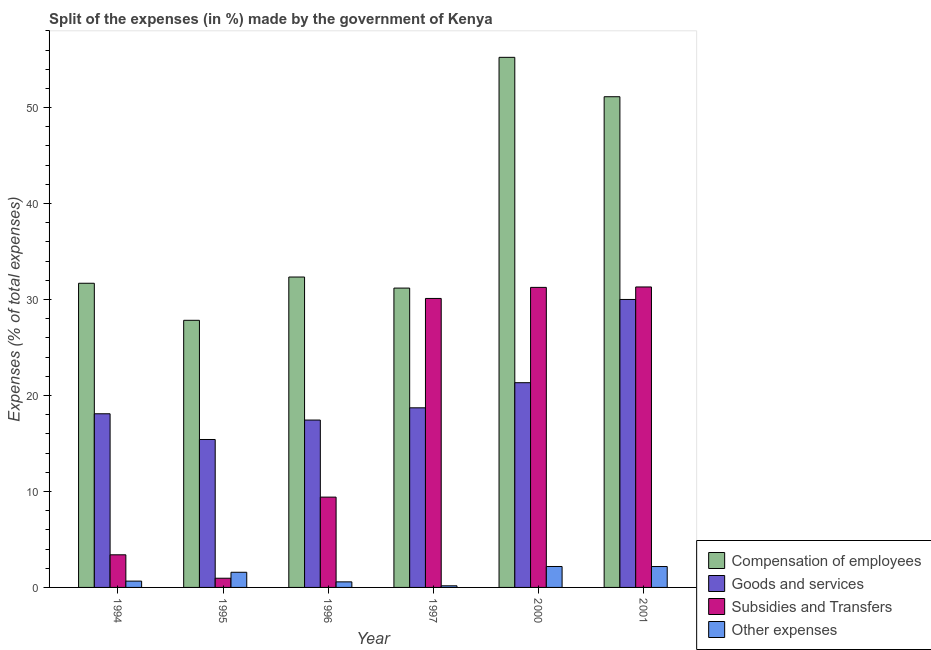How many different coloured bars are there?
Provide a succinct answer. 4. How many groups of bars are there?
Give a very brief answer. 6. Are the number of bars per tick equal to the number of legend labels?
Keep it short and to the point. Yes. How many bars are there on the 1st tick from the left?
Keep it short and to the point. 4. How many bars are there on the 5th tick from the right?
Make the answer very short. 4. What is the label of the 2nd group of bars from the left?
Provide a short and direct response. 1995. What is the percentage of amount spent on goods and services in 1994?
Ensure brevity in your answer.  18.1. Across all years, what is the maximum percentage of amount spent on compensation of employees?
Offer a terse response. 55.24. Across all years, what is the minimum percentage of amount spent on other expenses?
Your response must be concise. 0.17. What is the total percentage of amount spent on compensation of employees in the graph?
Make the answer very short. 229.44. What is the difference between the percentage of amount spent on subsidies in 1994 and that in 1995?
Ensure brevity in your answer.  2.44. What is the difference between the percentage of amount spent on compensation of employees in 1995 and the percentage of amount spent on goods and services in 2001?
Give a very brief answer. -23.3. What is the average percentage of amount spent on other expenses per year?
Your answer should be very brief. 1.22. In the year 1995, what is the difference between the percentage of amount spent on goods and services and percentage of amount spent on other expenses?
Provide a short and direct response. 0. In how many years, is the percentage of amount spent on subsidies greater than 50 %?
Your answer should be very brief. 0. What is the ratio of the percentage of amount spent on other expenses in 1997 to that in 2001?
Provide a succinct answer. 0.08. Is the percentage of amount spent on compensation of employees in 1997 less than that in 2000?
Keep it short and to the point. Yes. What is the difference between the highest and the second highest percentage of amount spent on compensation of employees?
Provide a succinct answer. 4.11. What is the difference between the highest and the lowest percentage of amount spent on subsidies?
Your answer should be very brief. 30.35. What does the 2nd bar from the left in 1997 represents?
Your response must be concise. Goods and services. What does the 4th bar from the right in 2000 represents?
Provide a short and direct response. Compensation of employees. Are all the bars in the graph horizontal?
Provide a succinct answer. No. How many years are there in the graph?
Keep it short and to the point. 6. What is the difference between two consecutive major ticks on the Y-axis?
Ensure brevity in your answer.  10. Are the values on the major ticks of Y-axis written in scientific E-notation?
Make the answer very short. No. Does the graph contain any zero values?
Your response must be concise. No. Does the graph contain grids?
Your answer should be compact. No. Where does the legend appear in the graph?
Ensure brevity in your answer.  Bottom right. What is the title of the graph?
Give a very brief answer. Split of the expenses (in %) made by the government of Kenya. Does "Services" appear as one of the legend labels in the graph?
Your response must be concise. No. What is the label or title of the Y-axis?
Keep it short and to the point. Expenses (% of total expenses). What is the Expenses (% of total expenses) in Compensation of employees in 1994?
Offer a very short reply. 31.7. What is the Expenses (% of total expenses) of Goods and services in 1994?
Offer a very short reply. 18.1. What is the Expenses (% of total expenses) of Subsidies and Transfers in 1994?
Ensure brevity in your answer.  3.4. What is the Expenses (% of total expenses) of Other expenses in 1994?
Your response must be concise. 0.66. What is the Expenses (% of total expenses) in Compensation of employees in 1995?
Provide a short and direct response. 27.84. What is the Expenses (% of total expenses) in Goods and services in 1995?
Keep it short and to the point. 15.42. What is the Expenses (% of total expenses) of Subsidies and Transfers in 1995?
Ensure brevity in your answer.  0.96. What is the Expenses (% of total expenses) in Other expenses in 1995?
Keep it short and to the point. 1.58. What is the Expenses (% of total expenses) of Compensation of employees in 1996?
Offer a very short reply. 32.35. What is the Expenses (% of total expenses) in Goods and services in 1996?
Give a very brief answer. 17.44. What is the Expenses (% of total expenses) in Subsidies and Transfers in 1996?
Ensure brevity in your answer.  9.41. What is the Expenses (% of total expenses) of Other expenses in 1996?
Give a very brief answer. 0.58. What is the Expenses (% of total expenses) of Compensation of employees in 1997?
Offer a very short reply. 31.19. What is the Expenses (% of total expenses) in Goods and services in 1997?
Make the answer very short. 18.72. What is the Expenses (% of total expenses) in Subsidies and Transfers in 1997?
Offer a terse response. 30.11. What is the Expenses (% of total expenses) of Other expenses in 1997?
Make the answer very short. 0.17. What is the Expenses (% of total expenses) of Compensation of employees in 2000?
Offer a very short reply. 55.24. What is the Expenses (% of total expenses) of Goods and services in 2000?
Offer a very short reply. 21.33. What is the Expenses (% of total expenses) of Subsidies and Transfers in 2000?
Your answer should be compact. 31.27. What is the Expenses (% of total expenses) of Other expenses in 2000?
Offer a terse response. 2.18. What is the Expenses (% of total expenses) in Compensation of employees in 2001?
Provide a short and direct response. 51.13. What is the Expenses (% of total expenses) of Goods and services in 2001?
Offer a very short reply. 30.01. What is the Expenses (% of total expenses) in Subsidies and Transfers in 2001?
Offer a terse response. 31.31. What is the Expenses (% of total expenses) of Other expenses in 2001?
Make the answer very short. 2.18. Across all years, what is the maximum Expenses (% of total expenses) in Compensation of employees?
Offer a terse response. 55.24. Across all years, what is the maximum Expenses (% of total expenses) of Goods and services?
Offer a terse response. 30.01. Across all years, what is the maximum Expenses (% of total expenses) in Subsidies and Transfers?
Your answer should be very brief. 31.31. Across all years, what is the maximum Expenses (% of total expenses) of Other expenses?
Your answer should be very brief. 2.18. Across all years, what is the minimum Expenses (% of total expenses) in Compensation of employees?
Offer a very short reply. 27.84. Across all years, what is the minimum Expenses (% of total expenses) in Goods and services?
Your response must be concise. 15.42. Across all years, what is the minimum Expenses (% of total expenses) in Subsidies and Transfers?
Ensure brevity in your answer.  0.96. Across all years, what is the minimum Expenses (% of total expenses) in Other expenses?
Your answer should be compact. 0.17. What is the total Expenses (% of total expenses) in Compensation of employees in the graph?
Offer a terse response. 229.44. What is the total Expenses (% of total expenses) of Goods and services in the graph?
Offer a terse response. 121.01. What is the total Expenses (% of total expenses) of Subsidies and Transfers in the graph?
Offer a terse response. 106.46. What is the total Expenses (% of total expenses) of Other expenses in the graph?
Your answer should be compact. 7.35. What is the difference between the Expenses (% of total expenses) in Compensation of employees in 1994 and that in 1995?
Provide a short and direct response. 3.86. What is the difference between the Expenses (% of total expenses) of Goods and services in 1994 and that in 1995?
Ensure brevity in your answer.  2.68. What is the difference between the Expenses (% of total expenses) of Subsidies and Transfers in 1994 and that in 1995?
Your answer should be compact. 2.44. What is the difference between the Expenses (% of total expenses) of Other expenses in 1994 and that in 1995?
Your answer should be very brief. -0.92. What is the difference between the Expenses (% of total expenses) in Compensation of employees in 1994 and that in 1996?
Provide a short and direct response. -0.65. What is the difference between the Expenses (% of total expenses) in Goods and services in 1994 and that in 1996?
Ensure brevity in your answer.  0.65. What is the difference between the Expenses (% of total expenses) of Subsidies and Transfers in 1994 and that in 1996?
Give a very brief answer. -6.01. What is the difference between the Expenses (% of total expenses) of Other expenses in 1994 and that in 1996?
Provide a succinct answer. 0.08. What is the difference between the Expenses (% of total expenses) in Compensation of employees in 1994 and that in 1997?
Provide a short and direct response. 0.5. What is the difference between the Expenses (% of total expenses) in Goods and services in 1994 and that in 1997?
Offer a terse response. -0.62. What is the difference between the Expenses (% of total expenses) in Subsidies and Transfers in 1994 and that in 1997?
Offer a very short reply. -26.72. What is the difference between the Expenses (% of total expenses) in Other expenses in 1994 and that in 1997?
Your answer should be compact. 0.49. What is the difference between the Expenses (% of total expenses) in Compensation of employees in 1994 and that in 2000?
Offer a very short reply. -23.54. What is the difference between the Expenses (% of total expenses) in Goods and services in 1994 and that in 2000?
Make the answer very short. -3.24. What is the difference between the Expenses (% of total expenses) in Subsidies and Transfers in 1994 and that in 2000?
Keep it short and to the point. -27.87. What is the difference between the Expenses (% of total expenses) in Other expenses in 1994 and that in 2000?
Provide a short and direct response. -1.52. What is the difference between the Expenses (% of total expenses) in Compensation of employees in 1994 and that in 2001?
Ensure brevity in your answer.  -19.44. What is the difference between the Expenses (% of total expenses) in Goods and services in 1994 and that in 2001?
Ensure brevity in your answer.  -11.91. What is the difference between the Expenses (% of total expenses) of Subsidies and Transfers in 1994 and that in 2001?
Offer a terse response. -27.91. What is the difference between the Expenses (% of total expenses) in Other expenses in 1994 and that in 2001?
Offer a very short reply. -1.52. What is the difference between the Expenses (% of total expenses) of Compensation of employees in 1995 and that in 1996?
Offer a very short reply. -4.51. What is the difference between the Expenses (% of total expenses) of Goods and services in 1995 and that in 1996?
Your answer should be compact. -2.03. What is the difference between the Expenses (% of total expenses) in Subsidies and Transfers in 1995 and that in 1996?
Offer a very short reply. -8.45. What is the difference between the Expenses (% of total expenses) of Compensation of employees in 1995 and that in 1997?
Your answer should be very brief. -3.36. What is the difference between the Expenses (% of total expenses) in Goods and services in 1995 and that in 1997?
Give a very brief answer. -3.3. What is the difference between the Expenses (% of total expenses) in Subsidies and Transfers in 1995 and that in 1997?
Your response must be concise. -29.16. What is the difference between the Expenses (% of total expenses) of Other expenses in 1995 and that in 1997?
Your answer should be very brief. 1.41. What is the difference between the Expenses (% of total expenses) of Compensation of employees in 1995 and that in 2000?
Your answer should be compact. -27.4. What is the difference between the Expenses (% of total expenses) of Goods and services in 1995 and that in 2000?
Provide a succinct answer. -5.92. What is the difference between the Expenses (% of total expenses) in Subsidies and Transfers in 1995 and that in 2000?
Provide a succinct answer. -30.31. What is the difference between the Expenses (% of total expenses) in Other expenses in 1995 and that in 2000?
Make the answer very short. -0.6. What is the difference between the Expenses (% of total expenses) of Compensation of employees in 1995 and that in 2001?
Your answer should be compact. -23.3. What is the difference between the Expenses (% of total expenses) of Goods and services in 1995 and that in 2001?
Make the answer very short. -14.59. What is the difference between the Expenses (% of total expenses) in Subsidies and Transfers in 1995 and that in 2001?
Ensure brevity in your answer.  -30.35. What is the difference between the Expenses (% of total expenses) in Other expenses in 1995 and that in 2001?
Offer a very short reply. -0.6. What is the difference between the Expenses (% of total expenses) of Compensation of employees in 1996 and that in 1997?
Ensure brevity in your answer.  1.15. What is the difference between the Expenses (% of total expenses) in Goods and services in 1996 and that in 1997?
Ensure brevity in your answer.  -1.27. What is the difference between the Expenses (% of total expenses) of Subsidies and Transfers in 1996 and that in 1997?
Provide a short and direct response. -20.7. What is the difference between the Expenses (% of total expenses) of Other expenses in 1996 and that in 1997?
Your answer should be very brief. 0.41. What is the difference between the Expenses (% of total expenses) in Compensation of employees in 1996 and that in 2000?
Your answer should be compact. -22.89. What is the difference between the Expenses (% of total expenses) of Goods and services in 1996 and that in 2000?
Keep it short and to the point. -3.89. What is the difference between the Expenses (% of total expenses) of Subsidies and Transfers in 1996 and that in 2000?
Offer a terse response. -21.86. What is the difference between the Expenses (% of total expenses) in Other expenses in 1996 and that in 2000?
Provide a short and direct response. -1.6. What is the difference between the Expenses (% of total expenses) of Compensation of employees in 1996 and that in 2001?
Keep it short and to the point. -18.79. What is the difference between the Expenses (% of total expenses) of Goods and services in 1996 and that in 2001?
Provide a short and direct response. -12.57. What is the difference between the Expenses (% of total expenses) in Subsidies and Transfers in 1996 and that in 2001?
Your response must be concise. -21.9. What is the difference between the Expenses (% of total expenses) in Other expenses in 1996 and that in 2001?
Your answer should be very brief. -1.6. What is the difference between the Expenses (% of total expenses) in Compensation of employees in 1997 and that in 2000?
Offer a very short reply. -24.05. What is the difference between the Expenses (% of total expenses) in Goods and services in 1997 and that in 2000?
Give a very brief answer. -2.62. What is the difference between the Expenses (% of total expenses) of Subsidies and Transfers in 1997 and that in 2000?
Your response must be concise. -1.15. What is the difference between the Expenses (% of total expenses) in Other expenses in 1997 and that in 2000?
Provide a short and direct response. -2.01. What is the difference between the Expenses (% of total expenses) in Compensation of employees in 1997 and that in 2001?
Your answer should be compact. -19.94. What is the difference between the Expenses (% of total expenses) in Goods and services in 1997 and that in 2001?
Your response must be concise. -11.29. What is the difference between the Expenses (% of total expenses) of Subsidies and Transfers in 1997 and that in 2001?
Your response must be concise. -1.2. What is the difference between the Expenses (% of total expenses) of Other expenses in 1997 and that in 2001?
Offer a very short reply. -2.01. What is the difference between the Expenses (% of total expenses) in Compensation of employees in 2000 and that in 2001?
Ensure brevity in your answer.  4.11. What is the difference between the Expenses (% of total expenses) of Goods and services in 2000 and that in 2001?
Give a very brief answer. -8.67. What is the difference between the Expenses (% of total expenses) in Subsidies and Transfers in 2000 and that in 2001?
Provide a succinct answer. -0.04. What is the difference between the Expenses (% of total expenses) in Other expenses in 2000 and that in 2001?
Make the answer very short. 0.01. What is the difference between the Expenses (% of total expenses) in Compensation of employees in 1994 and the Expenses (% of total expenses) in Goods and services in 1995?
Give a very brief answer. 16.28. What is the difference between the Expenses (% of total expenses) of Compensation of employees in 1994 and the Expenses (% of total expenses) of Subsidies and Transfers in 1995?
Make the answer very short. 30.74. What is the difference between the Expenses (% of total expenses) of Compensation of employees in 1994 and the Expenses (% of total expenses) of Other expenses in 1995?
Offer a terse response. 30.12. What is the difference between the Expenses (% of total expenses) of Goods and services in 1994 and the Expenses (% of total expenses) of Subsidies and Transfers in 1995?
Offer a terse response. 17.14. What is the difference between the Expenses (% of total expenses) in Goods and services in 1994 and the Expenses (% of total expenses) in Other expenses in 1995?
Keep it short and to the point. 16.52. What is the difference between the Expenses (% of total expenses) in Subsidies and Transfers in 1994 and the Expenses (% of total expenses) in Other expenses in 1995?
Your answer should be very brief. 1.82. What is the difference between the Expenses (% of total expenses) in Compensation of employees in 1994 and the Expenses (% of total expenses) in Goods and services in 1996?
Your response must be concise. 14.25. What is the difference between the Expenses (% of total expenses) of Compensation of employees in 1994 and the Expenses (% of total expenses) of Subsidies and Transfers in 1996?
Offer a very short reply. 22.29. What is the difference between the Expenses (% of total expenses) of Compensation of employees in 1994 and the Expenses (% of total expenses) of Other expenses in 1996?
Make the answer very short. 31.12. What is the difference between the Expenses (% of total expenses) of Goods and services in 1994 and the Expenses (% of total expenses) of Subsidies and Transfers in 1996?
Your response must be concise. 8.69. What is the difference between the Expenses (% of total expenses) in Goods and services in 1994 and the Expenses (% of total expenses) in Other expenses in 1996?
Give a very brief answer. 17.52. What is the difference between the Expenses (% of total expenses) of Subsidies and Transfers in 1994 and the Expenses (% of total expenses) of Other expenses in 1996?
Keep it short and to the point. 2.82. What is the difference between the Expenses (% of total expenses) in Compensation of employees in 1994 and the Expenses (% of total expenses) in Goods and services in 1997?
Keep it short and to the point. 12.98. What is the difference between the Expenses (% of total expenses) of Compensation of employees in 1994 and the Expenses (% of total expenses) of Subsidies and Transfers in 1997?
Keep it short and to the point. 1.58. What is the difference between the Expenses (% of total expenses) in Compensation of employees in 1994 and the Expenses (% of total expenses) in Other expenses in 1997?
Provide a succinct answer. 31.53. What is the difference between the Expenses (% of total expenses) in Goods and services in 1994 and the Expenses (% of total expenses) in Subsidies and Transfers in 1997?
Offer a very short reply. -12.02. What is the difference between the Expenses (% of total expenses) of Goods and services in 1994 and the Expenses (% of total expenses) of Other expenses in 1997?
Offer a terse response. 17.93. What is the difference between the Expenses (% of total expenses) of Subsidies and Transfers in 1994 and the Expenses (% of total expenses) of Other expenses in 1997?
Keep it short and to the point. 3.23. What is the difference between the Expenses (% of total expenses) in Compensation of employees in 1994 and the Expenses (% of total expenses) in Goods and services in 2000?
Offer a very short reply. 10.36. What is the difference between the Expenses (% of total expenses) of Compensation of employees in 1994 and the Expenses (% of total expenses) of Subsidies and Transfers in 2000?
Make the answer very short. 0.43. What is the difference between the Expenses (% of total expenses) of Compensation of employees in 1994 and the Expenses (% of total expenses) of Other expenses in 2000?
Your response must be concise. 29.51. What is the difference between the Expenses (% of total expenses) in Goods and services in 1994 and the Expenses (% of total expenses) in Subsidies and Transfers in 2000?
Your response must be concise. -13.17. What is the difference between the Expenses (% of total expenses) of Goods and services in 1994 and the Expenses (% of total expenses) of Other expenses in 2000?
Ensure brevity in your answer.  15.91. What is the difference between the Expenses (% of total expenses) in Subsidies and Transfers in 1994 and the Expenses (% of total expenses) in Other expenses in 2000?
Offer a very short reply. 1.22. What is the difference between the Expenses (% of total expenses) of Compensation of employees in 1994 and the Expenses (% of total expenses) of Goods and services in 2001?
Offer a very short reply. 1.69. What is the difference between the Expenses (% of total expenses) of Compensation of employees in 1994 and the Expenses (% of total expenses) of Subsidies and Transfers in 2001?
Your answer should be very brief. 0.39. What is the difference between the Expenses (% of total expenses) of Compensation of employees in 1994 and the Expenses (% of total expenses) of Other expenses in 2001?
Your answer should be very brief. 29.52. What is the difference between the Expenses (% of total expenses) in Goods and services in 1994 and the Expenses (% of total expenses) in Subsidies and Transfers in 2001?
Your answer should be very brief. -13.21. What is the difference between the Expenses (% of total expenses) of Goods and services in 1994 and the Expenses (% of total expenses) of Other expenses in 2001?
Keep it short and to the point. 15.92. What is the difference between the Expenses (% of total expenses) in Subsidies and Transfers in 1994 and the Expenses (% of total expenses) in Other expenses in 2001?
Ensure brevity in your answer.  1.22. What is the difference between the Expenses (% of total expenses) of Compensation of employees in 1995 and the Expenses (% of total expenses) of Goods and services in 1996?
Your response must be concise. 10.39. What is the difference between the Expenses (% of total expenses) of Compensation of employees in 1995 and the Expenses (% of total expenses) of Subsidies and Transfers in 1996?
Give a very brief answer. 18.42. What is the difference between the Expenses (% of total expenses) of Compensation of employees in 1995 and the Expenses (% of total expenses) of Other expenses in 1996?
Keep it short and to the point. 27.26. What is the difference between the Expenses (% of total expenses) in Goods and services in 1995 and the Expenses (% of total expenses) in Subsidies and Transfers in 1996?
Ensure brevity in your answer.  6. What is the difference between the Expenses (% of total expenses) of Goods and services in 1995 and the Expenses (% of total expenses) of Other expenses in 1996?
Offer a very short reply. 14.84. What is the difference between the Expenses (% of total expenses) in Subsidies and Transfers in 1995 and the Expenses (% of total expenses) in Other expenses in 1996?
Offer a very short reply. 0.38. What is the difference between the Expenses (% of total expenses) of Compensation of employees in 1995 and the Expenses (% of total expenses) of Goods and services in 1997?
Provide a short and direct response. 9.12. What is the difference between the Expenses (% of total expenses) of Compensation of employees in 1995 and the Expenses (% of total expenses) of Subsidies and Transfers in 1997?
Your response must be concise. -2.28. What is the difference between the Expenses (% of total expenses) in Compensation of employees in 1995 and the Expenses (% of total expenses) in Other expenses in 1997?
Give a very brief answer. 27.67. What is the difference between the Expenses (% of total expenses) of Goods and services in 1995 and the Expenses (% of total expenses) of Subsidies and Transfers in 1997?
Provide a succinct answer. -14.7. What is the difference between the Expenses (% of total expenses) in Goods and services in 1995 and the Expenses (% of total expenses) in Other expenses in 1997?
Your answer should be very brief. 15.25. What is the difference between the Expenses (% of total expenses) in Subsidies and Transfers in 1995 and the Expenses (% of total expenses) in Other expenses in 1997?
Offer a terse response. 0.79. What is the difference between the Expenses (% of total expenses) of Compensation of employees in 1995 and the Expenses (% of total expenses) of Goods and services in 2000?
Make the answer very short. 6.5. What is the difference between the Expenses (% of total expenses) of Compensation of employees in 1995 and the Expenses (% of total expenses) of Subsidies and Transfers in 2000?
Your answer should be compact. -3.43. What is the difference between the Expenses (% of total expenses) in Compensation of employees in 1995 and the Expenses (% of total expenses) in Other expenses in 2000?
Offer a terse response. 25.65. What is the difference between the Expenses (% of total expenses) in Goods and services in 1995 and the Expenses (% of total expenses) in Subsidies and Transfers in 2000?
Provide a succinct answer. -15.85. What is the difference between the Expenses (% of total expenses) of Goods and services in 1995 and the Expenses (% of total expenses) of Other expenses in 2000?
Make the answer very short. 13.23. What is the difference between the Expenses (% of total expenses) of Subsidies and Transfers in 1995 and the Expenses (% of total expenses) of Other expenses in 2000?
Give a very brief answer. -1.22. What is the difference between the Expenses (% of total expenses) in Compensation of employees in 1995 and the Expenses (% of total expenses) in Goods and services in 2001?
Offer a terse response. -2.17. What is the difference between the Expenses (% of total expenses) in Compensation of employees in 1995 and the Expenses (% of total expenses) in Subsidies and Transfers in 2001?
Offer a very short reply. -3.48. What is the difference between the Expenses (% of total expenses) of Compensation of employees in 1995 and the Expenses (% of total expenses) of Other expenses in 2001?
Your answer should be compact. 25.66. What is the difference between the Expenses (% of total expenses) in Goods and services in 1995 and the Expenses (% of total expenses) in Subsidies and Transfers in 2001?
Offer a terse response. -15.9. What is the difference between the Expenses (% of total expenses) of Goods and services in 1995 and the Expenses (% of total expenses) of Other expenses in 2001?
Provide a succinct answer. 13.24. What is the difference between the Expenses (% of total expenses) of Subsidies and Transfers in 1995 and the Expenses (% of total expenses) of Other expenses in 2001?
Keep it short and to the point. -1.22. What is the difference between the Expenses (% of total expenses) of Compensation of employees in 1996 and the Expenses (% of total expenses) of Goods and services in 1997?
Make the answer very short. 13.63. What is the difference between the Expenses (% of total expenses) of Compensation of employees in 1996 and the Expenses (% of total expenses) of Subsidies and Transfers in 1997?
Make the answer very short. 2.23. What is the difference between the Expenses (% of total expenses) of Compensation of employees in 1996 and the Expenses (% of total expenses) of Other expenses in 1997?
Keep it short and to the point. 32.18. What is the difference between the Expenses (% of total expenses) in Goods and services in 1996 and the Expenses (% of total expenses) in Subsidies and Transfers in 1997?
Your response must be concise. -12.67. What is the difference between the Expenses (% of total expenses) in Goods and services in 1996 and the Expenses (% of total expenses) in Other expenses in 1997?
Keep it short and to the point. 17.27. What is the difference between the Expenses (% of total expenses) of Subsidies and Transfers in 1996 and the Expenses (% of total expenses) of Other expenses in 1997?
Your response must be concise. 9.24. What is the difference between the Expenses (% of total expenses) of Compensation of employees in 1996 and the Expenses (% of total expenses) of Goods and services in 2000?
Offer a terse response. 11.01. What is the difference between the Expenses (% of total expenses) in Compensation of employees in 1996 and the Expenses (% of total expenses) in Subsidies and Transfers in 2000?
Your response must be concise. 1.08. What is the difference between the Expenses (% of total expenses) of Compensation of employees in 1996 and the Expenses (% of total expenses) of Other expenses in 2000?
Provide a succinct answer. 30.16. What is the difference between the Expenses (% of total expenses) in Goods and services in 1996 and the Expenses (% of total expenses) in Subsidies and Transfers in 2000?
Give a very brief answer. -13.83. What is the difference between the Expenses (% of total expenses) of Goods and services in 1996 and the Expenses (% of total expenses) of Other expenses in 2000?
Your answer should be very brief. 15.26. What is the difference between the Expenses (% of total expenses) of Subsidies and Transfers in 1996 and the Expenses (% of total expenses) of Other expenses in 2000?
Your response must be concise. 7.23. What is the difference between the Expenses (% of total expenses) of Compensation of employees in 1996 and the Expenses (% of total expenses) of Goods and services in 2001?
Keep it short and to the point. 2.34. What is the difference between the Expenses (% of total expenses) in Compensation of employees in 1996 and the Expenses (% of total expenses) in Subsidies and Transfers in 2001?
Your answer should be very brief. 1.03. What is the difference between the Expenses (% of total expenses) of Compensation of employees in 1996 and the Expenses (% of total expenses) of Other expenses in 2001?
Provide a short and direct response. 30.17. What is the difference between the Expenses (% of total expenses) of Goods and services in 1996 and the Expenses (% of total expenses) of Subsidies and Transfers in 2001?
Make the answer very short. -13.87. What is the difference between the Expenses (% of total expenses) in Goods and services in 1996 and the Expenses (% of total expenses) in Other expenses in 2001?
Provide a short and direct response. 15.26. What is the difference between the Expenses (% of total expenses) in Subsidies and Transfers in 1996 and the Expenses (% of total expenses) in Other expenses in 2001?
Provide a short and direct response. 7.23. What is the difference between the Expenses (% of total expenses) of Compensation of employees in 1997 and the Expenses (% of total expenses) of Goods and services in 2000?
Your answer should be compact. 9.86. What is the difference between the Expenses (% of total expenses) in Compensation of employees in 1997 and the Expenses (% of total expenses) in Subsidies and Transfers in 2000?
Your response must be concise. -0.07. What is the difference between the Expenses (% of total expenses) of Compensation of employees in 1997 and the Expenses (% of total expenses) of Other expenses in 2000?
Provide a succinct answer. 29.01. What is the difference between the Expenses (% of total expenses) of Goods and services in 1997 and the Expenses (% of total expenses) of Subsidies and Transfers in 2000?
Offer a very short reply. -12.55. What is the difference between the Expenses (% of total expenses) of Goods and services in 1997 and the Expenses (% of total expenses) of Other expenses in 2000?
Your answer should be very brief. 16.53. What is the difference between the Expenses (% of total expenses) in Subsidies and Transfers in 1997 and the Expenses (% of total expenses) in Other expenses in 2000?
Offer a terse response. 27.93. What is the difference between the Expenses (% of total expenses) in Compensation of employees in 1997 and the Expenses (% of total expenses) in Goods and services in 2001?
Keep it short and to the point. 1.19. What is the difference between the Expenses (% of total expenses) of Compensation of employees in 1997 and the Expenses (% of total expenses) of Subsidies and Transfers in 2001?
Offer a very short reply. -0.12. What is the difference between the Expenses (% of total expenses) of Compensation of employees in 1997 and the Expenses (% of total expenses) of Other expenses in 2001?
Make the answer very short. 29.02. What is the difference between the Expenses (% of total expenses) of Goods and services in 1997 and the Expenses (% of total expenses) of Subsidies and Transfers in 2001?
Provide a succinct answer. -12.59. What is the difference between the Expenses (% of total expenses) of Goods and services in 1997 and the Expenses (% of total expenses) of Other expenses in 2001?
Keep it short and to the point. 16.54. What is the difference between the Expenses (% of total expenses) of Subsidies and Transfers in 1997 and the Expenses (% of total expenses) of Other expenses in 2001?
Offer a terse response. 27.94. What is the difference between the Expenses (% of total expenses) in Compensation of employees in 2000 and the Expenses (% of total expenses) in Goods and services in 2001?
Ensure brevity in your answer.  25.23. What is the difference between the Expenses (% of total expenses) of Compensation of employees in 2000 and the Expenses (% of total expenses) of Subsidies and Transfers in 2001?
Provide a short and direct response. 23.93. What is the difference between the Expenses (% of total expenses) of Compensation of employees in 2000 and the Expenses (% of total expenses) of Other expenses in 2001?
Ensure brevity in your answer.  53.06. What is the difference between the Expenses (% of total expenses) in Goods and services in 2000 and the Expenses (% of total expenses) in Subsidies and Transfers in 2001?
Give a very brief answer. -9.98. What is the difference between the Expenses (% of total expenses) in Goods and services in 2000 and the Expenses (% of total expenses) in Other expenses in 2001?
Provide a succinct answer. 19.16. What is the difference between the Expenses (% of total expenses) of Subsidies and Transfers in 2000 and the Expenses (% of total expenses) of Other expenses in 2001?
Your answer should be very brief. 29.09. What is the average Expenses (% of total expenses) of Compensation of employees per year?
Provide a succinct answer. 38.24. What is the average Expenses (% of total expenses) in Goods and services per year?
Make the answer very short. 20.17. What is the average Expenses (% of total expenses) in Subsidies and Transfers per year?
Your answer should be very brief. 17.74. What is the average Expenses (% of total expenses) of Other expenses per year?
Keep it short and to the point. 1.22. In the year 1994, what is the difference between the Expenses (% of total expenses) in Compensation of employees and Expenses (% of total expenses) in Goods and services?
Provide a short and direct response. 13.6. In the year 1994, what is the difference between the Expenses (% of total expenses) in Compensation of employees and Expenses (% of total expenses) in Subsidies and Transfers?
Make the answer very short. 28.3. In the year 1994, what is the difference between the Expenses (% of total expenses) in Compensation of employees and Expenses (% of total expenses) in Other expenses?
Give a very brief answer. 31.04. In the year 1994, what is the difference between the Expenses (% of total expenses) in Goods and services and Expenses (% of total expenses) in Subsidies and Transfers?
Keep it short and to the point. 14.7. In the year 1994, what is the difference between the Expenses (% of total expenses) of Goods and services and Expenses (% of total expenses) of Other expenses?
Your answer should be very brief. 17.44. In the year 1994, what is the difference between the Expenses (% of total expenses) of Subsidies and Transfers and Expenses (% of total expenses) of Other expenses?
Provide a succinct answer. 2.74. In the year 1995, what is the difference between the Expenses (% of total expenses) of Compensation of employees and Expenses (% of total expenses) of Goods and services?
Offer a very short reply. 12.42. In the year 1995, what is the difference between the Expenses (% of total expenses) of Compensation of employees and Expenses (% of total expenses) of Subsidies and Transfers?
Offer a terse response. 26.88. In the year 1995, what is the difference between the Expenses (% of total expenses) in Compensation of employees and Expenses (% of total expenses) in Other expenses?
Your answer should be compact. 26.26. In the year 1995, what is the difference between the Expenses (% of total expenses) in Goods and services and Expenses (% of total expenses) in Subsidies and Transfers?
Make the answer very short. 14.46. In the year 1995, what is the difference between the Expenses (% of total expenses) of Goods and services and Expenses (% of total expenses) of Other expenses?
Keep it short and to the point. 13.84. In the year 1995, what is the difference between the Expenses (% of total expenses) of Subsidies and Transfers and Expenses (% of total expenses) of Other expenses?
Your answer should be very brief. -0.62. In the year 1996, what is the difference between the Expenses (% of total expenses) of Compensation of employees and Expenses (% of total expenses) of Goods and services?
Offer a very short reply. 14.9. In the year 1996, what is the difference between the Expenses (% of total expenses) in Compensation of employees and Expenses (% of total expenses) in Subsidies and Transfers?
Keep it short and to the point. 22.93. In the year 1996, what is the difference between the Expenses (% of total expenses) of Compensation of employees and Expenses (% of total expenses) of Other expenses?
Your response must be concise. 31.77. In the year 1996, what is the difference between the Expenses (% of total expenses) in Goods and services and Expenses (% of total expenses) in Subsidies and Transfers?
Provide a short and direct response. 8.03. In the year 1996, what is the difference between the Expenses (% of total expenses) in Goods and services and Expenses (% of total expenses) in Other expenses?
Offer a very short reply. 16.86. In the year 1996, what is the difference between the Expenses (% of total expenses) in Subsidies and Transfers and Expenses (% of total expenses) in Other expenses?
Make the answer very short. 8.83. In the year 1997, what is the difference between the Expenses (% of total expenses) in Compensation of employees and Expenses (% of total expenses) in Goods and services?
Keep it short and to the point. 12.48. In the year 1997, what is the difference between the Expenses (% of total expenses) of Compensation of employees and Expenses (% of total expenses) of Subsidies and Transfers?
Give a very brief answer. 1.08. In the year 1997, what is the difference between the Expenses (% of total expenses) of Compensation of employees and Expenses (% of total expenses) of Other expenses?
Your answer should be very brief. 31.02. In the year 1997, what is the difference between the Expenses (% of total expenses) of Goods and services and Expenses (% of total expenses) of Subsidies and Transfers?
Provide a succinct answer. -11.4. In the year 1997, what is the difference between the Expenses (% of total expenses) in Goods and services and Expenses (% of total expenses) in Other expenses?
Your answer should be very brief. 18.55. In the year 1997, what is the difference between the Expenses (% of total expenses) in Subsidies and Transfers and Expenses (% of total expenses) in Other expenses?
Your answer should be very brief. 29.95. In the year 2000, what is the difference between the Expenses (% of total expenses) in Compensation of employees and Expenses (% of total expenses) in Goods and services?
Provide a succinct answer. 33.91. In the year 2000, what is the difference between the Expenses (% of total expenses) of Compensation of employees and Expenses (% of total expenses) of Subsidies and Transfers?
Provide a short and direct response. 23.97. In the year 2000, what is the difference between the Expenses (% of total expenses) of Compensation of employees and Expenses (% of total expenses) of Other expenses?
Keep it short and to the point. 53.06. In the year 2000, what is the difference between the Expenses (% of total expenses) of Goods and services and Expenses (% of total expenses) of Subsidies and Transfers?
Ensure brevity in your answer.  -9.93. In the year 2000, what is the difference between the Expenses (% of total expenses) of Goods and services and Expenses (% of total expenses) of Other expenses?
Offer a terse response. 19.15. In the year 2000, what is the difference between the Expenses (% of total expenses) of Subsidies and Transfers and Expenses (% of total expenses) of Other expenses?
Provide a short and direct response. 29.09. In the year 2001, what is the difference between the Expenses (% of total expenses) of Compensation of employees and Expenses (% of total expenses) of Goods and services?
Provide a short and direct response. 21.13. In the year 2001, what is the difference between the Expenses (% of total expenses) in Compensation of employees and Expenses (% of total expenses) in Subsidies and Transfers?
Your answer should be very brief. 19.82. In the year 2001, what is the difference between the Expenses (% of total expenses) in Compensation of employees and Expenses (% of total expenses) in Other expenses?
Provide a succinct answer. 48.96. In the year 2001, what is the difference between the Expenses (% of total expenses) in Goods and services and Expenses (% of total expenses) in Subsidies and Transfers?
Make the answer very short. -1.3. In the year 2001, what is the difference between the Expenses (% of total expenses) in Goods and services and Expenses (% of total expenses) in Other expenses?
Your answer should be compact. 27.83. In the year 2001, what is the difference between the Expenses (% of total expenses) of Subsidies and Transfers and Expenses (% of total expenses) of Other expenses?
Offer a very short reply. 29.13. What is the ratio of the Expenses (% of total expenses) of Compensation of employees in 1994 to that in 1995?
Give a very brief answer. 1.14. What is the ratio of the Expenses (% of total expenses) of Goods and services in 1994 to that in 1995?
Your response must be concise. 1.17. What is the ratio of the Expenses (% of total expenses) in Subsidies and Transfers in 1994 to that in 1995?
Provide a succinct answer. 3.54. What is the ratio of the Expenses (% of total expenses) in Other expenses in 1994 to that in 1995?
Your answer should be very brief. 0.42. What is the ratio of the Expenses (% of total expenses) of Compensation of employees in 1994 to that in 1996?
Offer a terse response. 0.98. What is the ratio of the Expenses (% of total expenses) of Goods and services in 1994 to that in 1996?
Make the answer very short. 1.04. What is the ratio of the Expenses (% of total expenses) in Subsidies and Transfers in 1994 to that in 1996?
Offer a terse response. 0.36. What is the ratio of the Expenses (% of total expenses) of Other expenses in 1994 to that in 1996?
Provide a succinct answer. 1.13. What is the ratio of the Expenses (% of total expenses) of Compensation of employees in 1994 to that in 1997?
Ensure brevity in your answer.  1.02. What is the ratio of the Expenses (% of total expenses) of Goods and services in 1994 to that in 1997?
Ensure brevity in your answer.  0.97. What is the ratio of the Expenses (% of total expenses) in Subsidies and Transfers in 1994 to that in 1997?
Give a very brief answer. 0.11. What is the ratio of the Expenses (% of total expenses) in Other expenses in 1994 to that in 1997?
Offer a very short reply. 3.89. What is the ratio of the Expenses (% of total expenses) of Compensation of employees in 1994 to that in 2000?
Provide a short and direct response. 0.57. What is the ratio of the Expenses (% of total expenses) in Goods and services in 1994 to that in 2000?
Ensure brevity in your answer.  0.85. What is the ratio of the Expenses (% of total expenses) in Subsidies and Transfers in 1994 to that in 2000?
Offer a very short reply. 0.11. What is the ratio of the Expenses (% of total expenses) of Other expenses in 1994 to that in 2000?
Your answer should be compact. 0.3. What is the ratio of the Expenses (% of total expenses) in Compensation of employees in 1994 to that in 2001?
Your answer should be very brief. 0.62. What is the ratio of the Expenses (% of total expenses) of Goods and services in 1994 to that in 2001?
Ensure brevity in your answer.  0.6. What is the ratio of the Expenses (% of total expenses) in Subsidies and Transfers in 1994 to that in 2001?
Provide a succinct answer. 0.11. What is the ratio of the Expenses (% of total expenses) of Other expenses in 1994 to that in 2001?
Provide a succinct answer. 0.3. What is the ratio of the Expenses (% of total expenses) of Compensation of employees in 1995 to that in 1996?
Offer a terse response. 0.86. What is the ratio of the Expenses (% of total expenses) in Goods and services in 1995 to that in 1996?
Your response must be concise. 0.88. What is the ratio of the Expenses (% of total expenses) of Subsidies and Transfers in 1995 to that in 1996?
Give a very brief answer. 0.1. What is the ratio of the Expenses (% of total expenses) in Other expenses in 1995 to that in 1996?
Make the answer very short. 2.72. What is the ratio of the Expenses (% of total expenses) of Compensation of employees in 1995 to that in 1997?
Ensure brevity in your answer.  0.89. What is the ratio of the Expenses (% of total expenses) of Goods and services in 1995 to that in 1997?
Ensure brevity in your answer.  0.82. What is the ratio of the Expenses (% of total expenses) in Subsidies and Transfers in 1995 to that in 1997?
Offer a terse response. 0.03. What is the ratio of the Expenses (% of total expenses) of Other expenses in 1995 to that in 1997?
Your answer should be very brief. 9.33. What is the ratio of the Expenses (% of total expenses) of Compensation of employees in 1995 to that in 2000?
Offer a very short reply. 0.5. What is the ratio of the Expenses (% of total expenses) in Goods and services in 1995 to that in 2000?
Keep it short and to the point. 0.72. What is the ratio of the Expenses (% of total expenses) in Subsidies and Transfers in 1995 to that in 2000?
Provide a short and direct response. 0.03. What is the ratio of the Expenses (% of total expenses) in Other expenses in 1995 to that in 2000?
Provide a short and direct response. 0.72. What is the ratio of the Expenses (% of total expenses) in Compensation of employees in 1995 to that in 2001?
Keep it short and to the point. 0.54. What is the ratio of the Expenses (% of total expenses) in Goods and services in 1995 to that in 2001?
Give a very brief answer. 0.51. What is the ratio of the Expenses (% of total expenses) in Subsidies and Transfers in 1995 to that in 2001?
Ensure brevity in your answer.  0.03. What is the ratio of the Expenses (% of total expenses) of Other expenses in 1995 to that in 2001?
Offer a terse response. 0.73. What is the ratio of the Expenses (% of total expenses) of Compensation of employees in 1996 to that in 1997?
Make the answer very short. 1.04. What is the ratio of the Expenses (% of total expenses) in Goods and services in 1996 to that in 1997?
Offer a very short reply. 0.93. What is the ratio of the Expenses (% of total expenses) in Subsidies and Transfers in 1996 to that in 1997?
Provide a succinct answer. 0.31. What is the ratio of the Expenses (% of total expenses) in Other expenses in 1996 to that in 1997?
Your answer should be very brief. 3.43. What is the ratio of the Expenses (% of total expenses) in Compensation of employees in 1996 to that in 2000?
Provide a short and direct response. 0.59. What is the ratio of the Expenses (% of total expenses) of Goods and services in 1996 to that in 2000?
Keep it short and to the point. 0.82. What is the ratio of the Expenses (% of total expenses) in Subsidies and Transfers in 1996 to that in 2000?
Offer a terse response. 0.3. What is the ratio of the Expenses (% of total expenses) in Other expenses in 1996 to that in 2000?
Provide a short and direct response. 0.27. What is the ratio of the Expenses (% of total expenses) in Compensation of employees in 1996 to that in 2001?
Offer a terse response. 0.63. What is the ratio of the Expenses (% of total expenses) in Goods and services in 1996 to that in 2001?
Offer a very short reply. 0.58. What is the ratio of the Expenses (% of total expenses) in Subsidies and Transfers in 1996 to that in 2001?
Offer a terse response. 0.3. What is the ratio of the Expenses (% of total expenses) in Other expenses in 1996 to that in 2001?
Provide a short and direct response. 0.27. What is the ratio of the Expenses (% of total expenses) in Compensation of employees in 1997 to that in 2000?
Offer a very short reply. 0.56. What is the ratio of the Expenses (% of total expenses) of Goods and services in 1997 to that in 2000?
Ensure brevity in your answer.  0.88. What is the ratio of the Expenses (% of total expenses) of Subsidies and Transfers in 1997 to that in 2000?
Offer a very short reply. 0.96. What is the ratio of the Expenses (% of total expenses) of Other expenses in 1997 to that in 2000?
Your answer should be very brief. 0.08. What is the ratio of the Expenses (% of total expenses) in Compensation of employees in 1997 to that in 2001?
Offer a terse response. 0.61. What is the ratio of the Expenses (% of total expenses) of Goods and services in 1997 to that in 2001?
Provide a succinct answer. 0.62. What is the ratio of the Expenses (% of total expenses) in Subsidies and Transfers in 1997 to that in 2001?
Your response must be concise. 0.96. What is the ratio of the Expenses (% of total expenses) of Other expenses in 1997 to that in 2001?
Your answer should be compact. 0.08. What is the ratio of the Expenses (% of total expenses) of Compensation of employees in 2000 to that in 2001?
Offer a terse response. 1.08. What is the ratio of the Expenses (% of total expenses) of Goods and services in 2000 to that in 2001?
Your answer should be compact. 0.71. What is the ratio of the Expenses (% of total expenses) of Subsidies and Transfers in 2000 to that in 2001?
Provide a short and direct response. 1. What is the difference between the highest and the second highest Expenses (% of total expenses) of Compensation of employees?
Your answer should be compact. 4.11. What is the difference between the highest and the second highest Expenses (% of total expenses) of Goods and services?
Your response must be concise. 8.67. What is the difference between the highest and the second highest Expenses (% of total expenses) of Subsidies and Transfers?
Provide a short and direct response. 0.04. What is the difference between the highest and the second highest Expenses (% of total expenses) in Other expenses?
Your response must be concise. 0.01. What is the difference between the highest and the lowest Expenses (% of total expenses) in Compensation of employees?
Ensure brevity in your answer.  27.4. What is the difference between the highest and the lowest Expenses (% of total expenses) of Goods and services?
Your answer should be compact. 14.59. What is the difference between the highest and the lowest Expenses (% of total expenses) of Subsidies and Transfers?
Your response must be concise. 30.35. What is the difference between the highest and the lowest Expenses (% of total expenses) of Other expenses?
Ensure brevity in your answer.  2.01. 